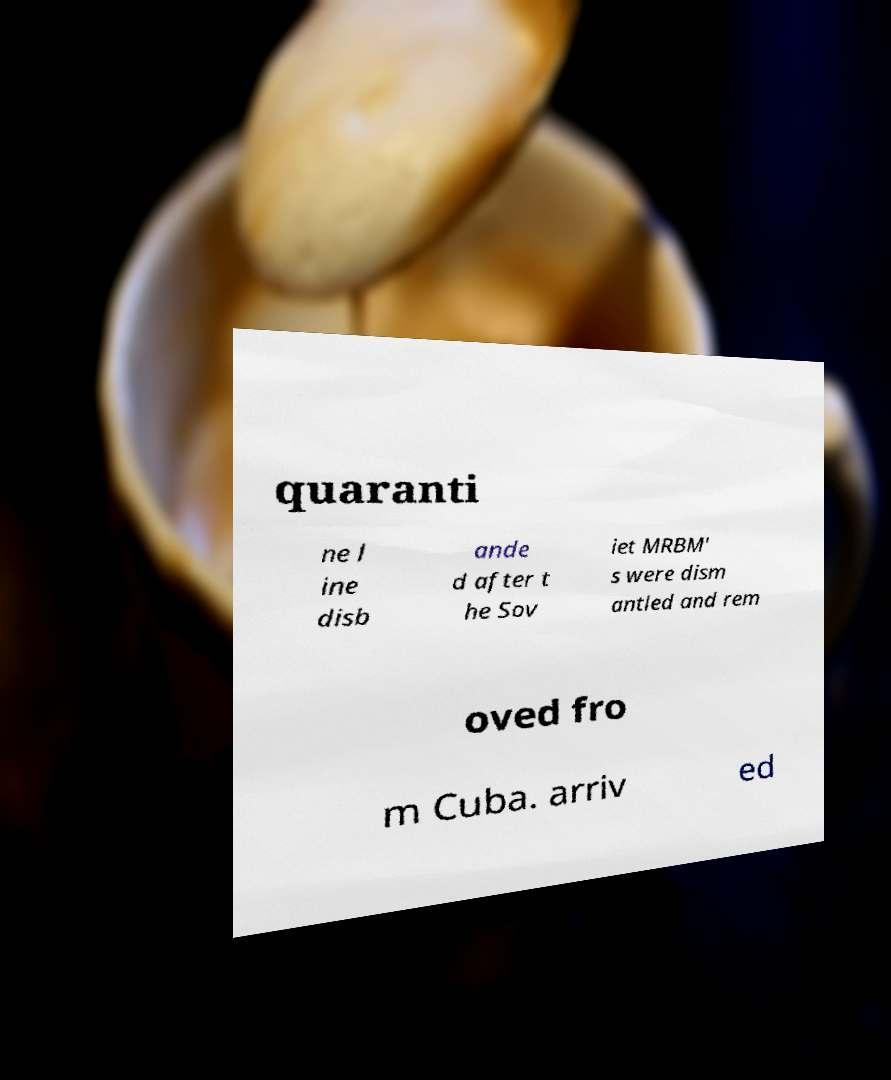Can you accurately transcribe the text from the provided image for me? quaranti ne l ine disb ande d after t he Sov iet MRBM' s were dism antled and rem oved fro m Cuba. arriv ed 